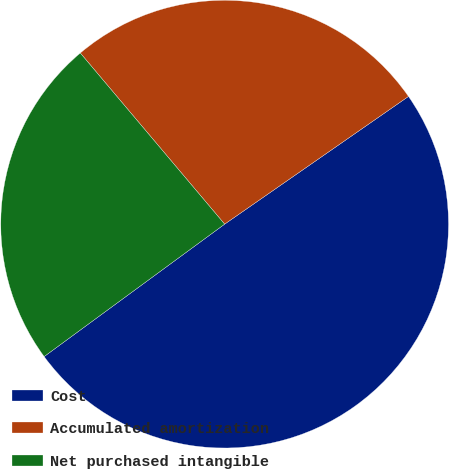<chart> <loc_0><loc_0><loc_500><loc_500><pie_chart><fcel>Cost<fcel>Accumulated amortization<fcel>Net purchased intangible<nl><fcel>49.59%<fcel>26.49%<fcel>23.92%<nl></chart> 